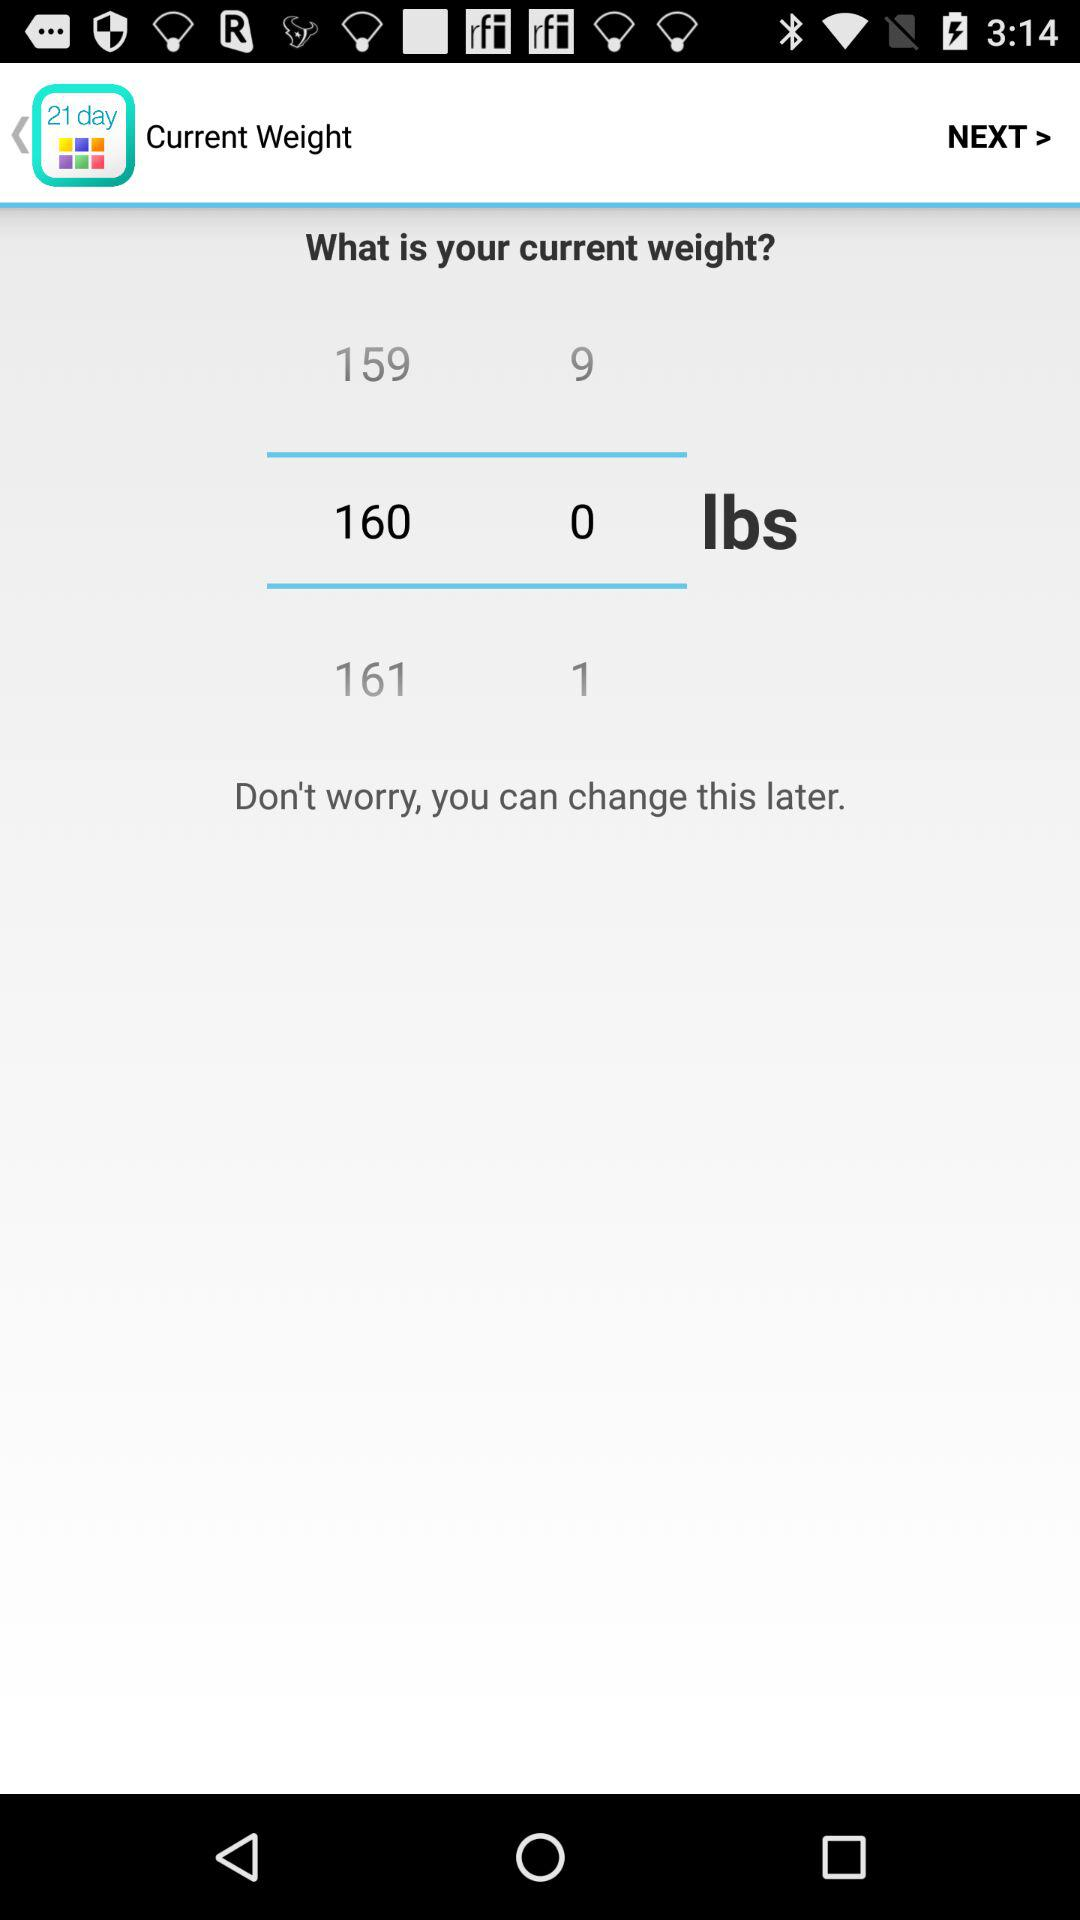How much weight is selected? The weight is 160.0 lbs. 